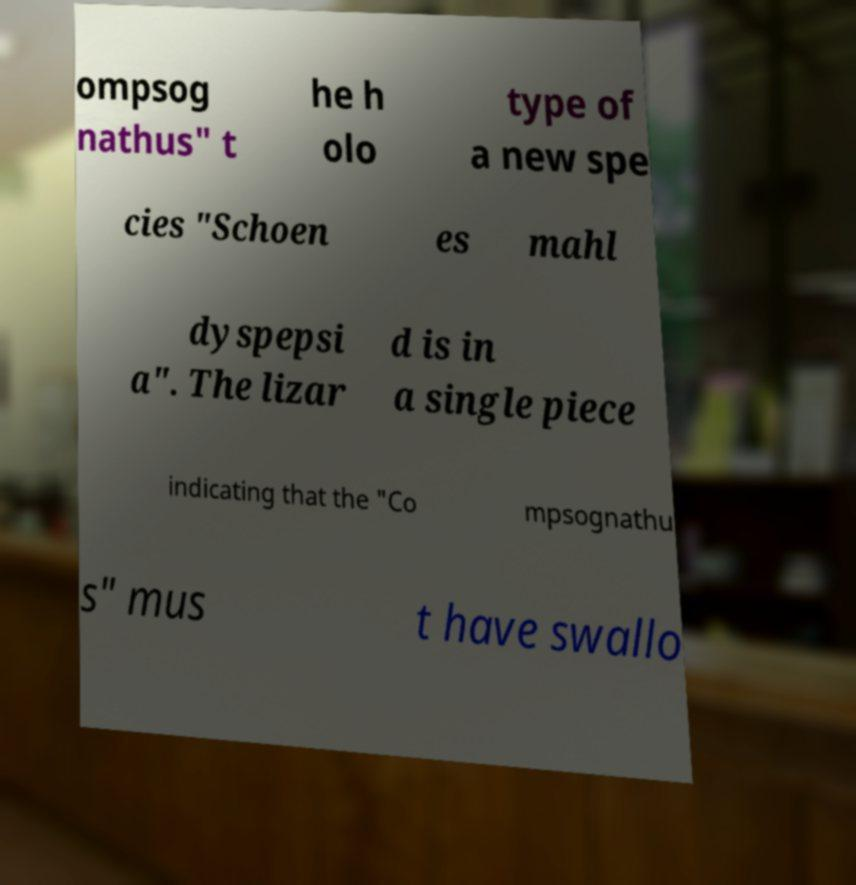What messages or text are displayed in this image? I need them in a readable, typed format. ompsog nathus" t he h olo type of a new spe cies "Schoen es mahl dyspepsi a". The lizar d is in a single piece indicating that the "Co mpsognathu s" mus t have swallo 